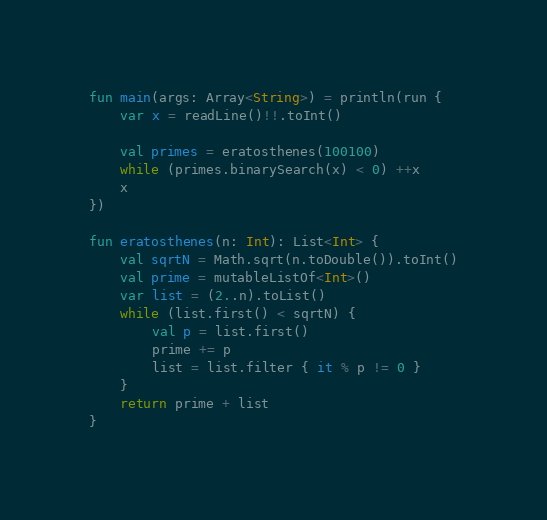Convert code to text. <code><loc_0><loc_0><loc_500><loc_500><_Kotlin_>fun main(args: Array<String>) = println(run {
    var x = readLine()!!.toInt()

    val primes = eratosthenes(100100)
    while (primes.binarySearch(x) < 0) ++x
    x
})

fun eratosthenes(n: Int): List<Int> {
    val sqrtN = Math.sqrt(n.toDouble()).toInt()
    val prime = mutableListOf<Int>()
    var list = (2..n).toList()
    while (list.first() < sqrtN) {
        val p = list.first()
        prime += p
        list = list.filter { it % p != 0 }
    }
    return prime + list
}</code> 